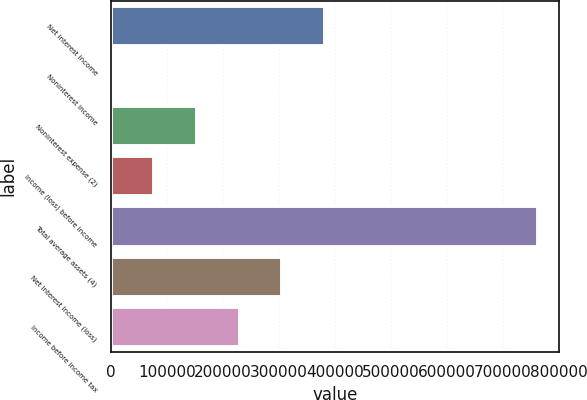Convert chart to OTSL. <chart><loc_0><loc_0><loc_500><loc_500><bar_chart><fcel>Net interest income<fcel>Noninterest income<fcel>Noninterest expense (2)<fcel>Income (loss) before income<fcel>Total average assets (4)<fcel>Net interest income (loss)<fcel>Income before income tax<nl><fcel>381934<fcel>681<fcel>153182<fcel>76931.5<fcel>763186<fcel>305683<fcel>229432<nl></chart> 